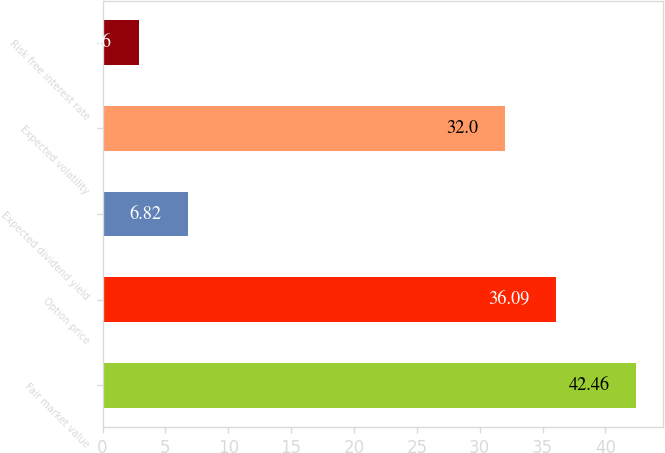Convert chart to OTSL. <chart><loc_0><loc_0><loc_500><loc_500><bar_chart><fcel>Fair market value<fcel>Option price<fcel>Expected dividend yield<fcel>Expected volatility<fcel>Risk free interest rate<nl><fcel>42.46<fcel>36.09<fcel>6.82<fcel>32<fcel>2.86<nl></chart> 